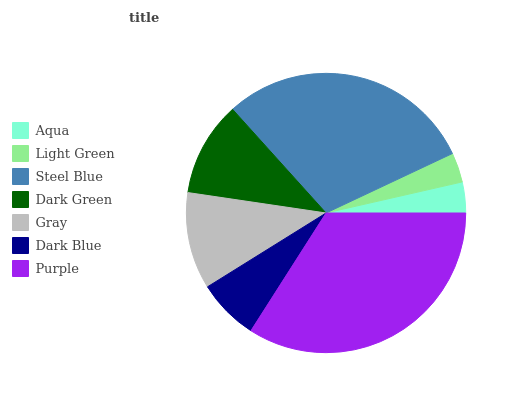Is Light Green the minimum?
Answer yes or no. Yes. Is Purple the maximum?
Answer yes or no. Yes. Is Steel Blue the minimum?
Answer yes or no. No. Is Steel Blue the maximum?
Answer yes or no. No. Is Steel Blue greater than Light Green?
Answer yes or no. Yes. Is Light Green less than Steel Blue?
Answer yes or no. Yes. Is Light Green greater than Steel Blue?
Answer yes or no. No. Is Steel Blue less than Light Green?
Answer yes or no. No. Is Dark Green the high median?
Answer yes or no. Yes. Is Dark Green the low median?
Answer yes or no. Yes. Is Purple the high median?
Answer yes or no. No. Is Purple the low median?
Answer yes or no. No. 